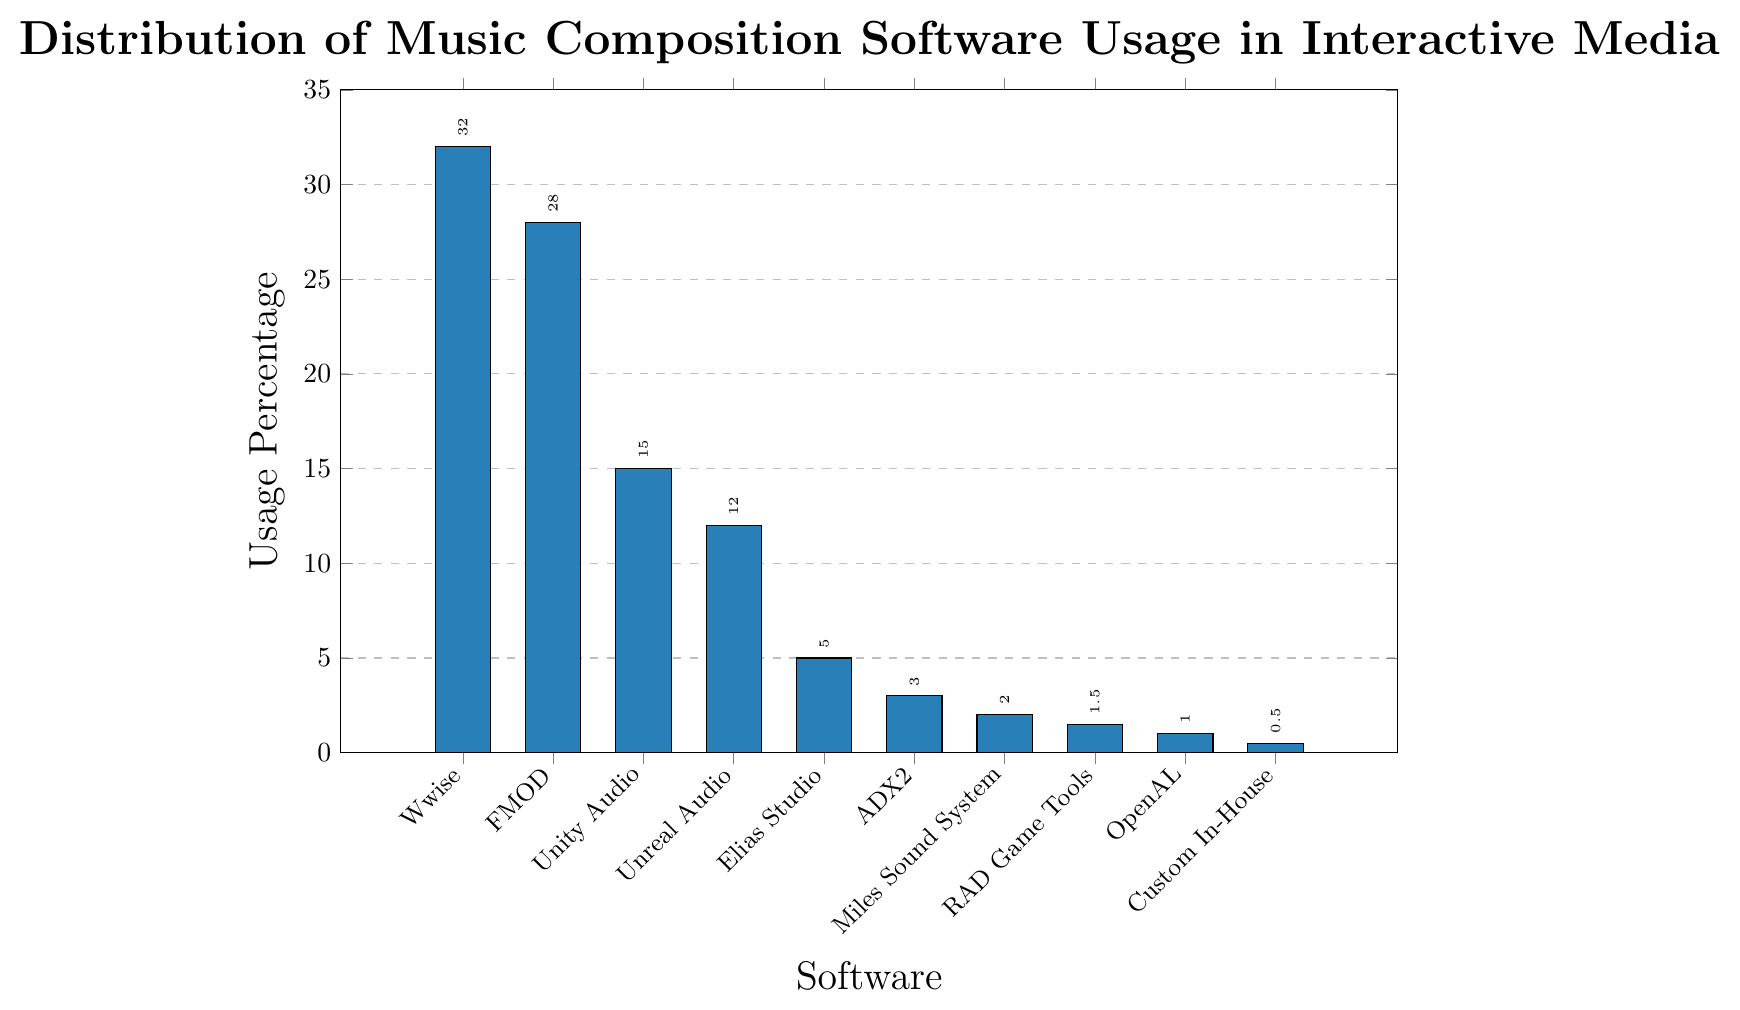Which software has the highest usage percentage? The bar chart shows that Wwise has the tallest bar, indicating it has the highest usage percentage.
Answer: Wwise What is the combined usage percentage of FMOD and Unity Audio? To find the combined usage, add the percentages for FMOD (28%) and Unity Audio (15%): 28 + 15 = 43.
Answer: 43% Which software has a higher usage percentage: Elias Studio or ADX2? The bar for Elias Studio is taller and has a 5% usage, while ADX2 has a 3% usage percentage.
Answer: Elias Studio By how much does Wwise's usage percentage exceed Unreal Audio's? Subtract the usage percentage of Unreal Audio (12%) from Wwise (32%): 32 - 12 = 20.
Answer: 20% What is the total usage percentage for all software listed? Sum the percentages of all the listed software: 32 + 28 + 15 + 12 + 5 + 3 + 2 + 1.5 + 1 + 0.5 = 100.
Answer: 100% Which three software tools have the lowest usage percentages? The three shortest bars are Custom In-House Solutions (0.5%), OpenAL (1%), and RAD Game Tools (1.5%).
Answer: Custom In-House Solutions, OpenAL, RAD Game Tools How much higher is the usage percentage of Wwise compared to the combined percentage of Elias Studio and ADX2? First, find the combined percentage of Elias Studio (5%) and ADX2 (3%): 5 + 3 = 8. Then, subtract this from Wwise's percentage (32): 32 - 8 = 24.
Answer: 24% What is the average usage percentage of the top four software tools? Sum the percentages of Wwise (32%), FMOD (28%), Unity Audio (15%), and Unreal Audio (12%): 32 + 28 + 15 + 12 = 87. Then, divide by 4: 87 / 4 = 21.75.
Answer: 21.75% What's the difference in usage percentage between the most and least used software? The most used software is Wwise (32%), and the least used is Custom In-House Solutions (0.5%): 32 - 0.5 = 31.5.
Answer: 31.5% 